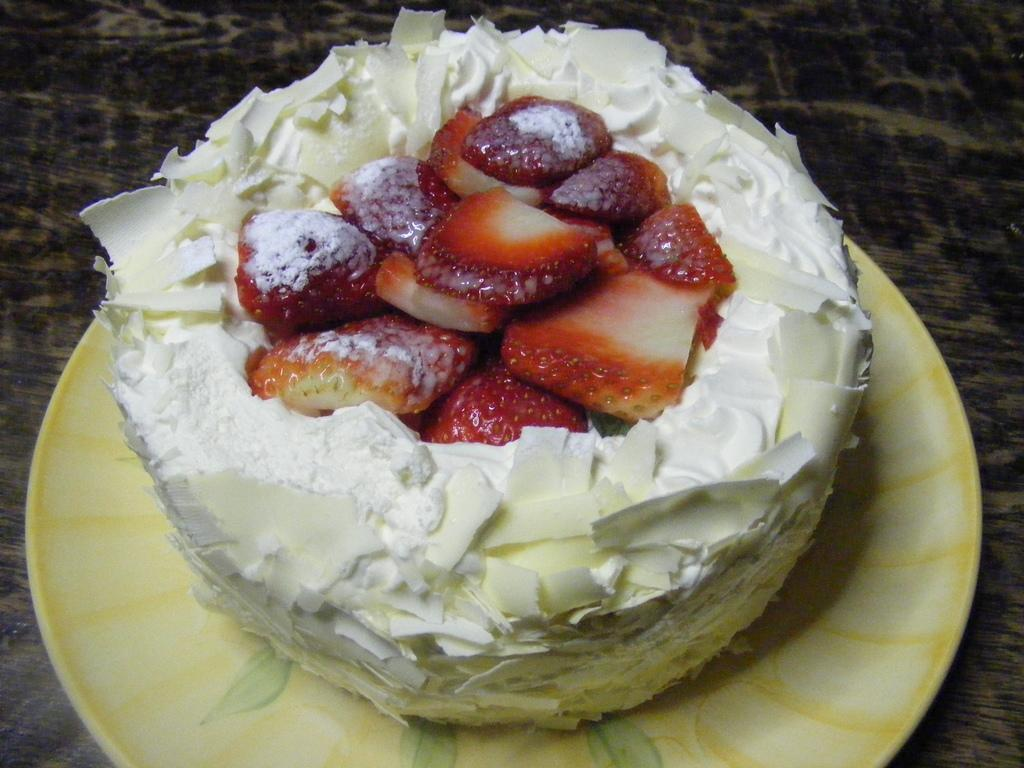What is the main subject of the image? There is a cake in the image. How is the cake presented? The cake is on a plate. What is the plate resting on? The plate is on a wooden surface. What decoration is on top of the cake? There are strawberry slices on top of the cake. What is the opinion of the quartz on the waves in the image? There is no quartz or waves present in the image; it features a cake on a plate with strawberry slices on top. 